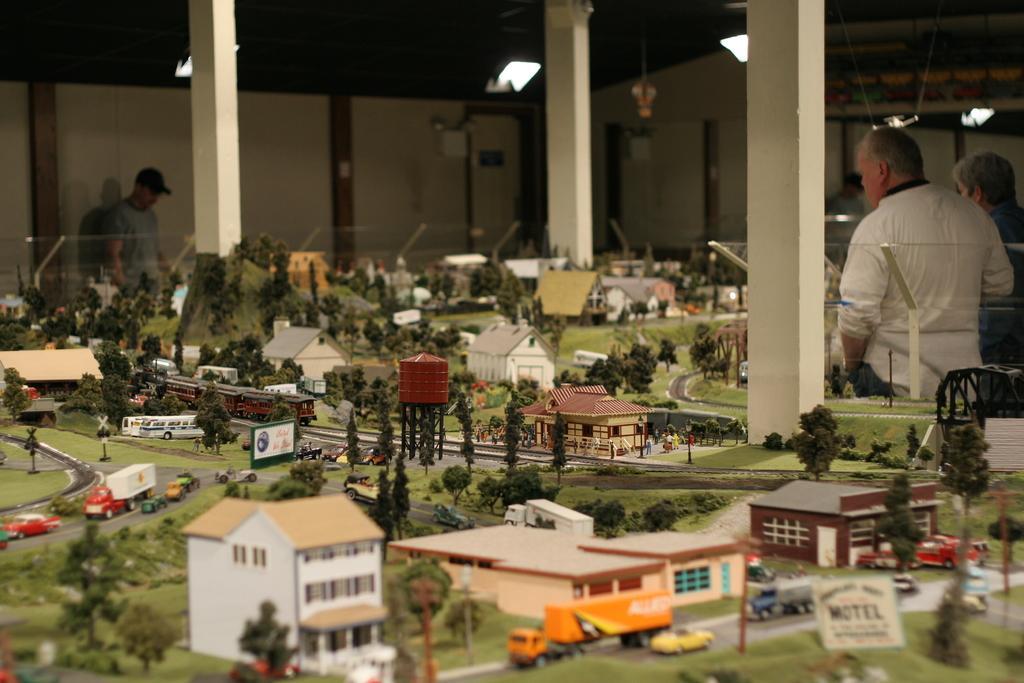Describe this image in one or two sentences. There is a model of a town is present at the bottom of this image. There are two persons standing on the right side of this image and one person is on the left side of this image. There is a wall in the background. There are three pillars are present as we can see at the top of this image. 